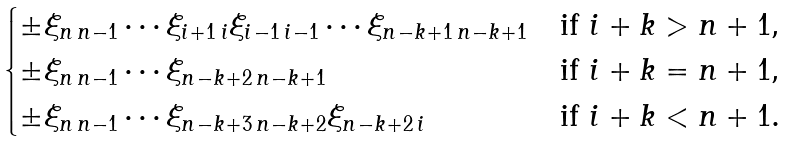Convert formula to latex. <formula><loc_0><loc_0><loc_500><loc_500>\begin{cases} \pm \xi _ { n \, n - 1 } \cdots \xi _ { i + 1 \, i } \xi _ { i - 1 \, i - 1 } \cdots \xi _ { n - k + 1 \, n - k + 1 } & \text {if $i+k>n+1$,} \\ \pm \xi _ { n \, n - 1 } \cdots \xi _ { n - k + 2 \, n - k + 1 } & \text {if $i+k=n+1$,} \\ \pm \xi _ { n \, n - 1 } \cdots \xi _ { n - k + 3 \, n - k + 2 } \xi _ { n - k + 2 \, i } & \text {if $i+k<n+1$.} \end{cases}</formula> 